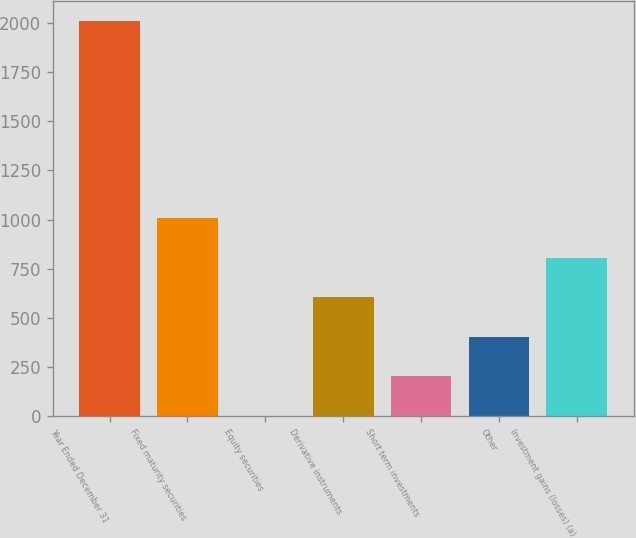Convert chart to OTSL. <chart><loc_0><loc_0><loc_500><loc_500><bar_chart><fcel>Year Ended December 31<fcel>Fixed maturity securities<fcel>Equity securities<fcel>Derivative instruments<fcel>Short term investments<fcel>Other<fcel>Investment gains (losses) (a)<nl><fcel>2010<fcel>1006<fcel>2<fcel>604.4<fcel>202.8<fcel>403.6<fcel>805.2<nl></chart> 